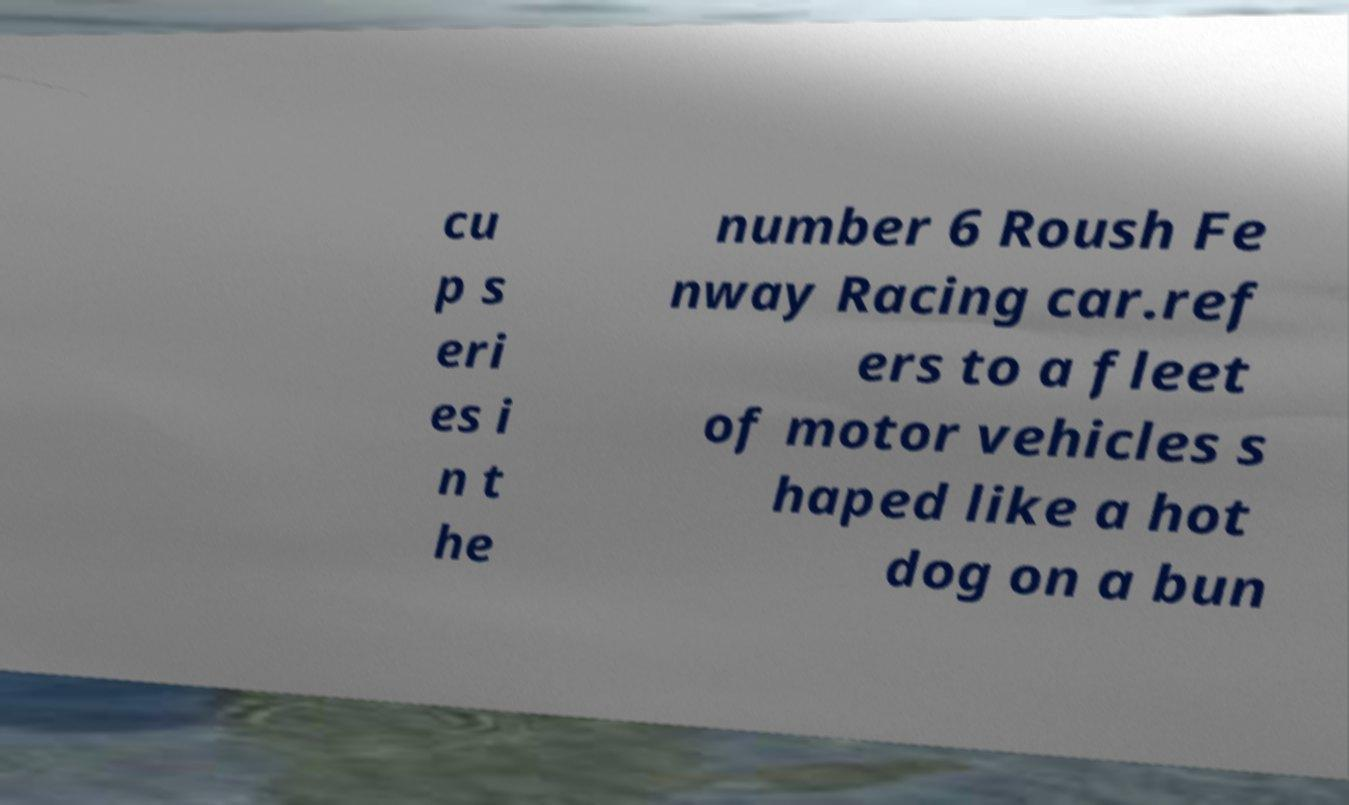Can you read and provide the text displayed in the image?This photo seems to have some interesting text. Can you extract and type it out for me? cu p s eri es i n t he number 6 Roush Fe nway Racing car.ref ers to a fleet of motor vehicles s haped like a hot dog on a bun 